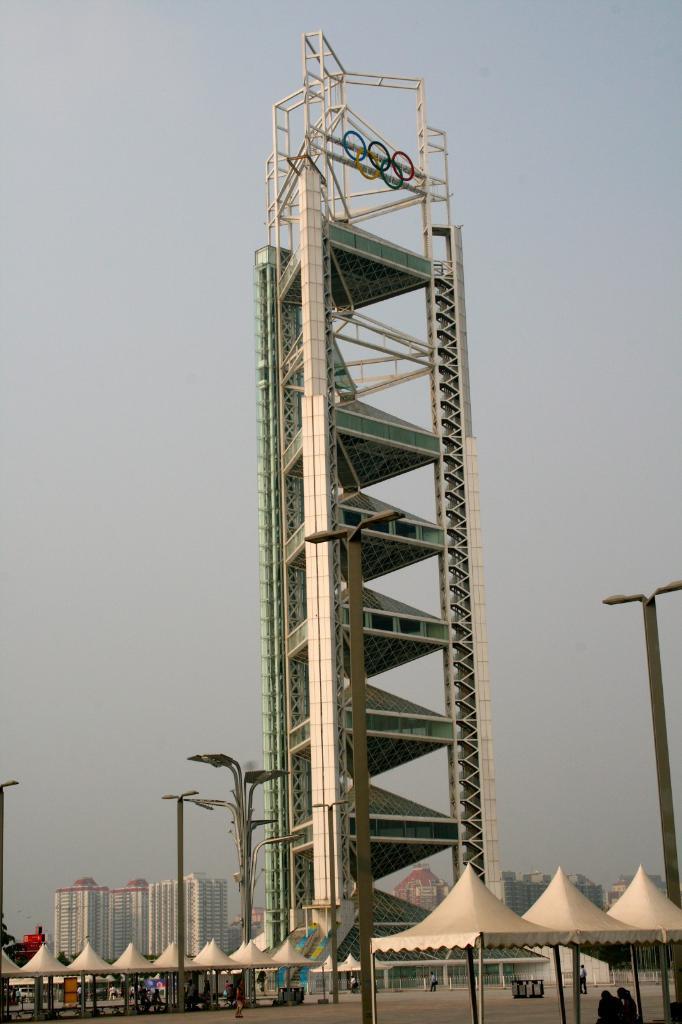In one or two sentences, can you explain what this image depicts? In this image I can see the tower which is in white and green color. In-front of the tower I can see few white color tents and I can see few people under the tents. There are also the poles to the side of the tents. In the background I can see many buildings and the sky. 